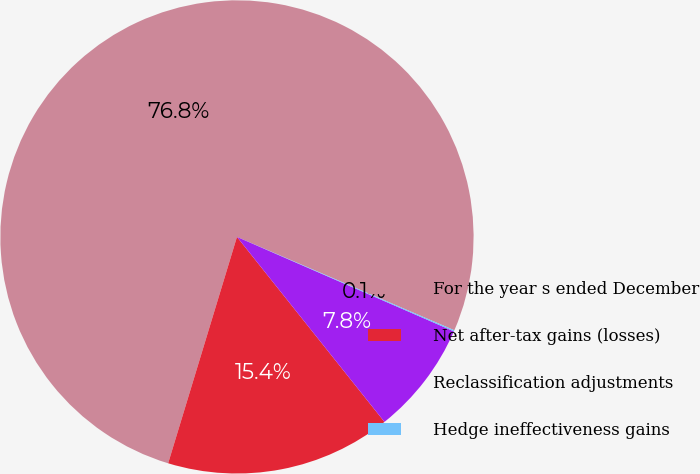<chart> <loc_0><loc_0><loc_500><loc_500><pie_chart><fcel>For the year s ended December<fcel>Net after-tax gains (losses)<fcel>Reclassification adjustments<fcel>Hedge ineffectiveness gains<nl><fcel>76.76%<fcel>15.41%<fcel>7.75%<fcel>0.08%<nl></chart> 